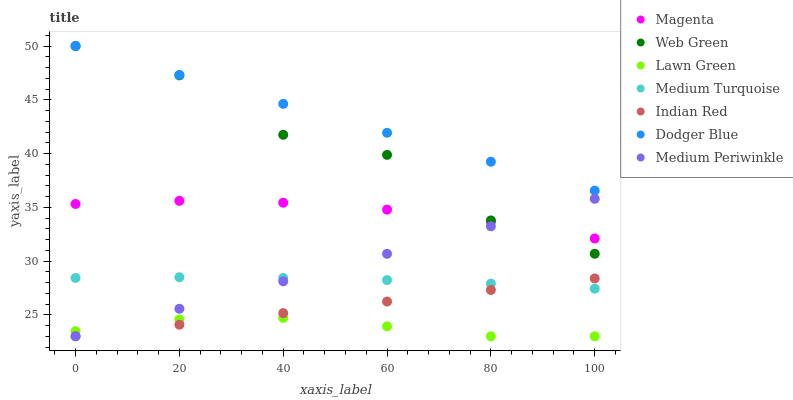Does Lawn Green have the minimum area under the curve?
Answer yes or no. Yes. Does Dodger Blue have the maximum area under the curve?
Answer yes or no. Yes. Does Medium Turquoise have the minimum area under the curve?
Answer yes or no. No. Does Medium Turquoise have the maximum area under the curve?
Answer yes or no. No. Is Indian Red the smoothest?
Answer yes or no. Yes. Is Web Green the roughest?
Answer yes or no. Yes. Is Medium Turquoise the smoothest?
Answer yes or no. No. Is Medium Turquoise the roughest?
Answer yes or no. No. Does Lawn Green have the lowest value?
Answer yes or no. Yes. Does Medium Turquoise have the lowest value?
Answer yes or no. No. Does Dodger Blue have the highest value?
Answer yes or no. Yes. Does Medium Turquoise have the highest value?
Answer yes or no. No. Is Medium Turquoise less than Web Green?
Answer yes or no. Yes. Is Dodger Blue greater than Lawn Green?
Answer yes or no. Yes. Does Web Green intersect Medium Periwinkle?
Answer yes or no. Yes. Is Web Green less than Medium Periwinkle?
Answer yes or no. No. Is Web Green greater than Medium Periwinkle?
Answer yes or no. No. Does Medium Turquoise intersect Web Green?
Answer yes or no. No. 